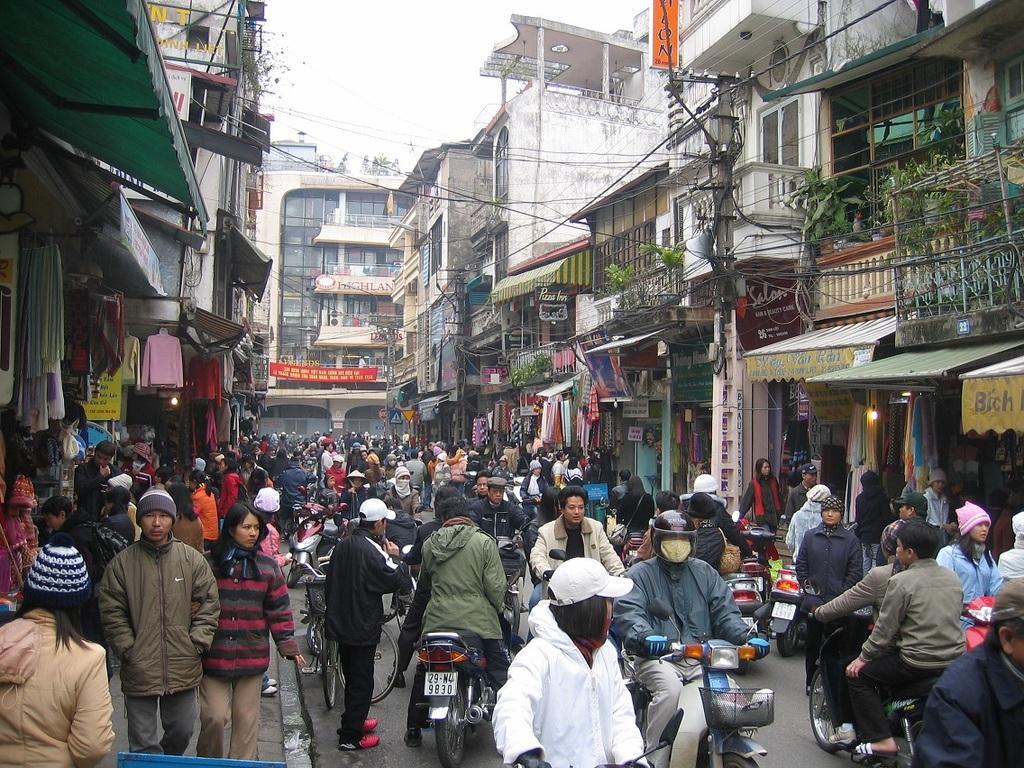Could you give a brief overview of what you see in this image? In this image, there is an outside view. There is a crowd in between buildings. There are some persons at the bottom of the image wearing clothes and riding bikes. There is a sky at the top of the image. 